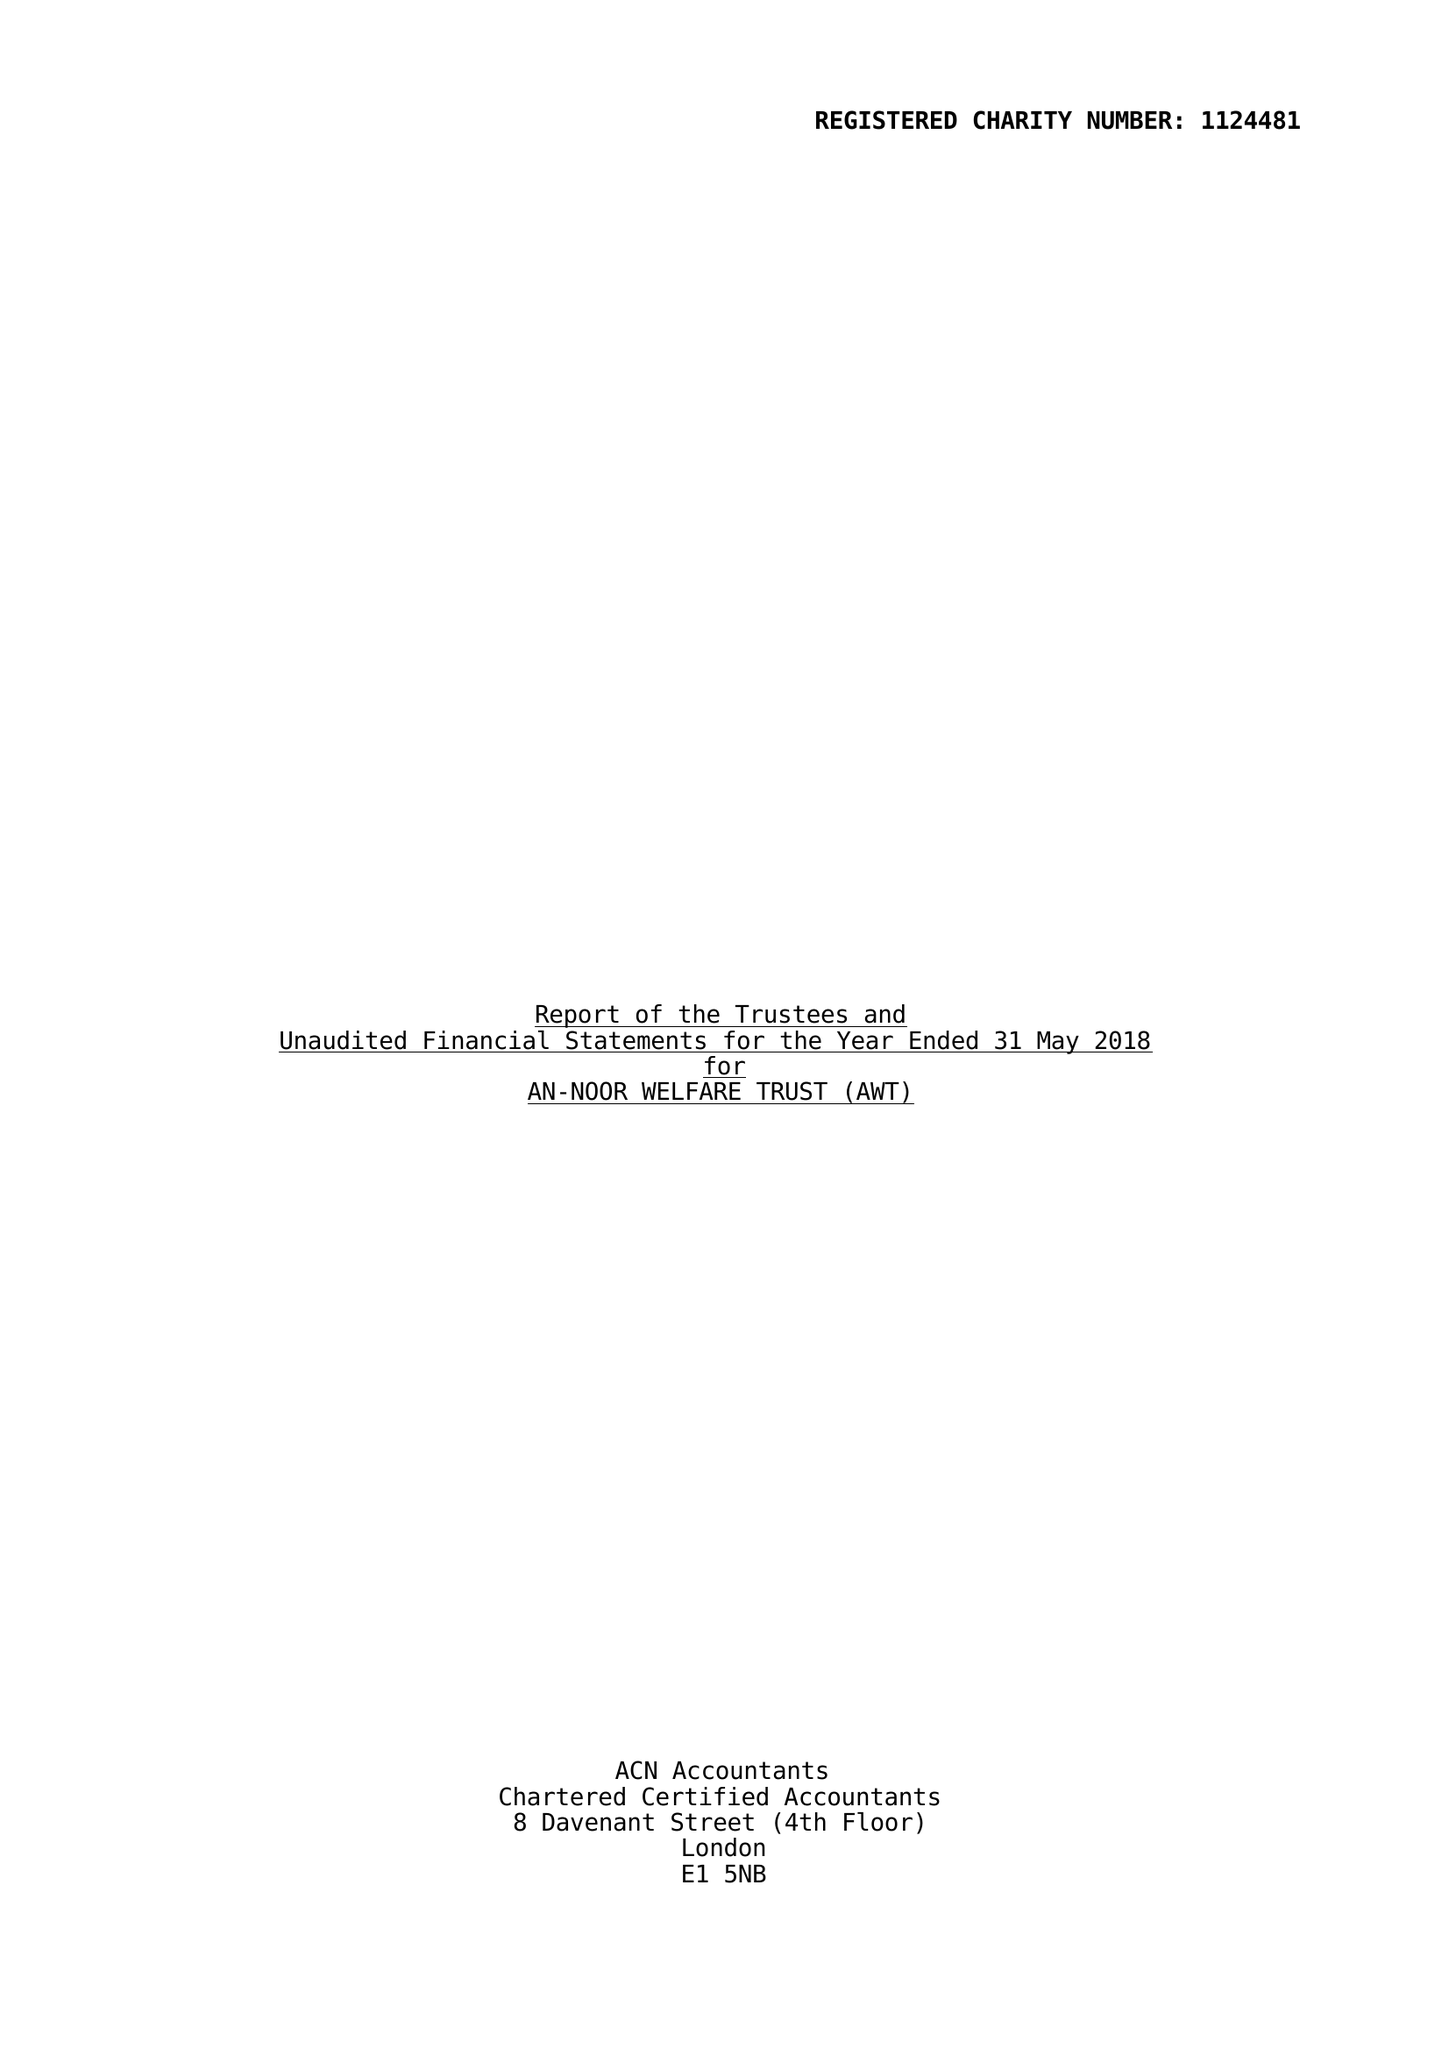What is the value for the charity_number?
Answer the question using a single word or phrase. 1124481 